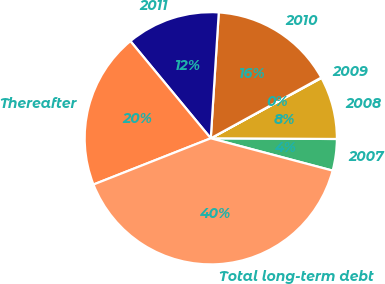<chart> <loc_0><loc_0><loc_500><loc_500><pie_chart><fcel>2007<fcel>2008<fcel>2009<fcel>2010<fcel>2011<fcel>Thereafter<fcel>Total long-term debt<nl><fcel>4.04%<fcel>8.03%<fcel>0.06%<fcel>15.99%<fcel>12.01%<fcel>19.98%<fcel>39.9%<nl></chart> 